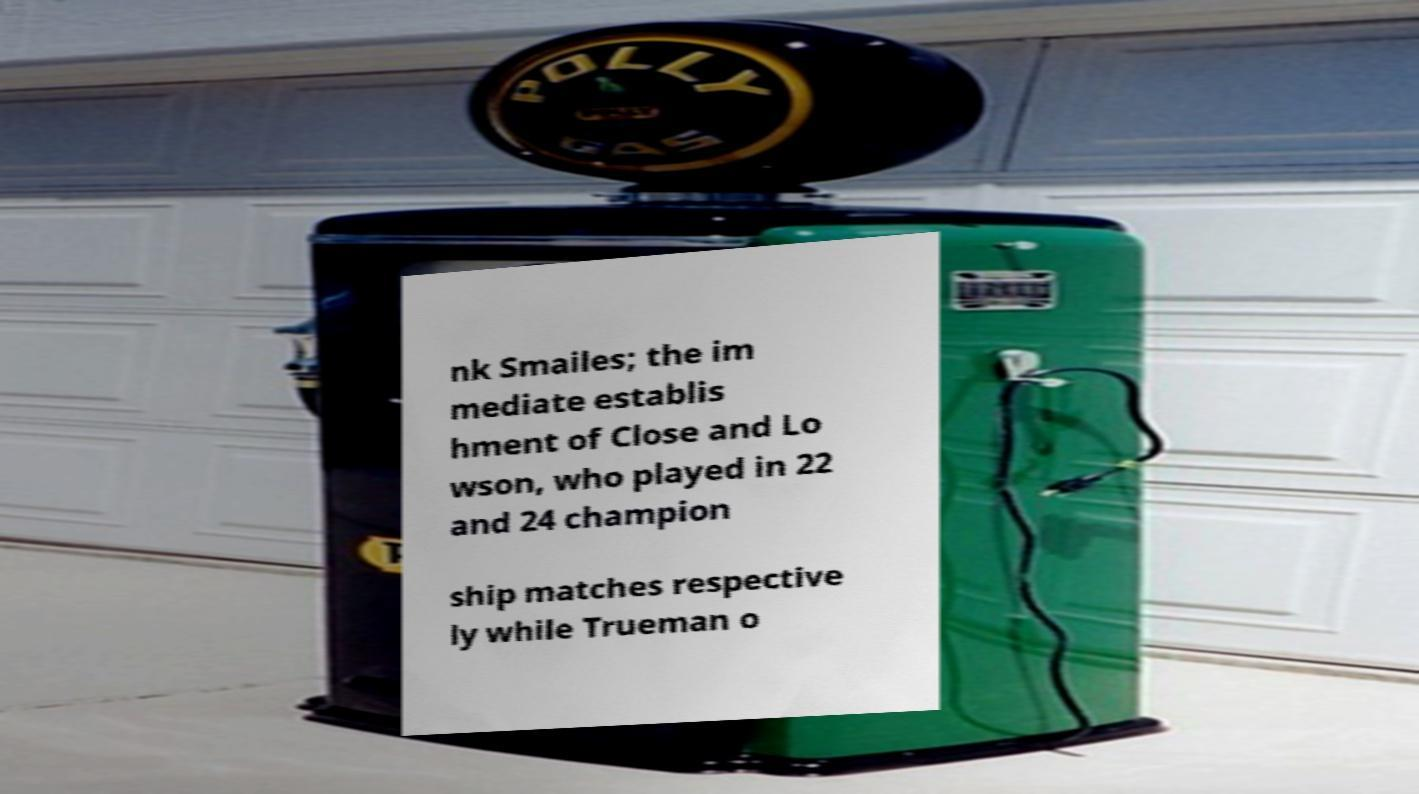Please read and relay the text visible in this image. What does it say? nk Smailes; the im mediate establis hment of Close and Lo wson, who played in 22 and 24 champion ship matches respective ly while Trueman o 